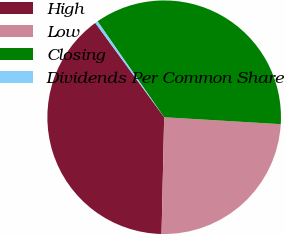Convert chart to OTSL. <chart><loc_0><loc_0><loc_500><loc_500><pie_chart><fcel>High<fcel>Low<fcel>Closing<fcel>Dividends Per Common Share<nl><fcel>39.6%<fcel>24.41%<fcel>35.6%<fcel>0.38%<nl></chart> 